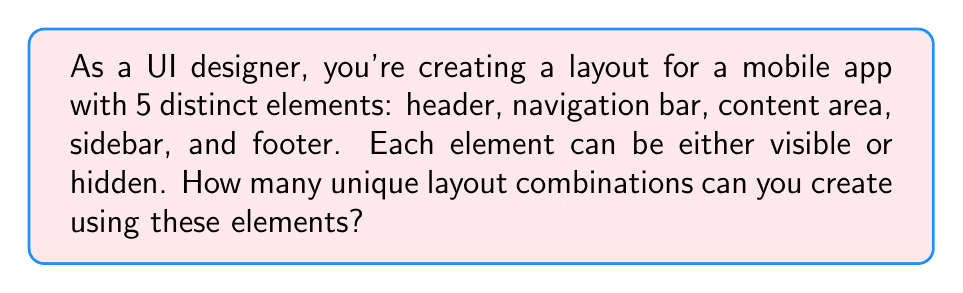Provide a solution to this math problem. Let's approach this step-by-step using Boolean combinatorics:

1) Each element has two possible states: visible (1) or hidden (0).

2) We have 5 independent elements, each with 2 possible states.

3) This scenario can be represented as a Boolean function with 5 variables, where each variable represents an element's state.

4) The number of possible combinations in a Boolean function is given by $2^n$, where n is the number of variables.

5) In this case, $n = 5$ (header, navigation bar, content area, sidebar, and footer).

6) Therefore, the number of unique layout combinations is:

   $$2^5 = 2 \times 2 \times 2 \times 2 \times 2 = 32$$

This means you can create 32 different UI layouts by toggling the visibility of these 5 elements.
Answer: $32$ 